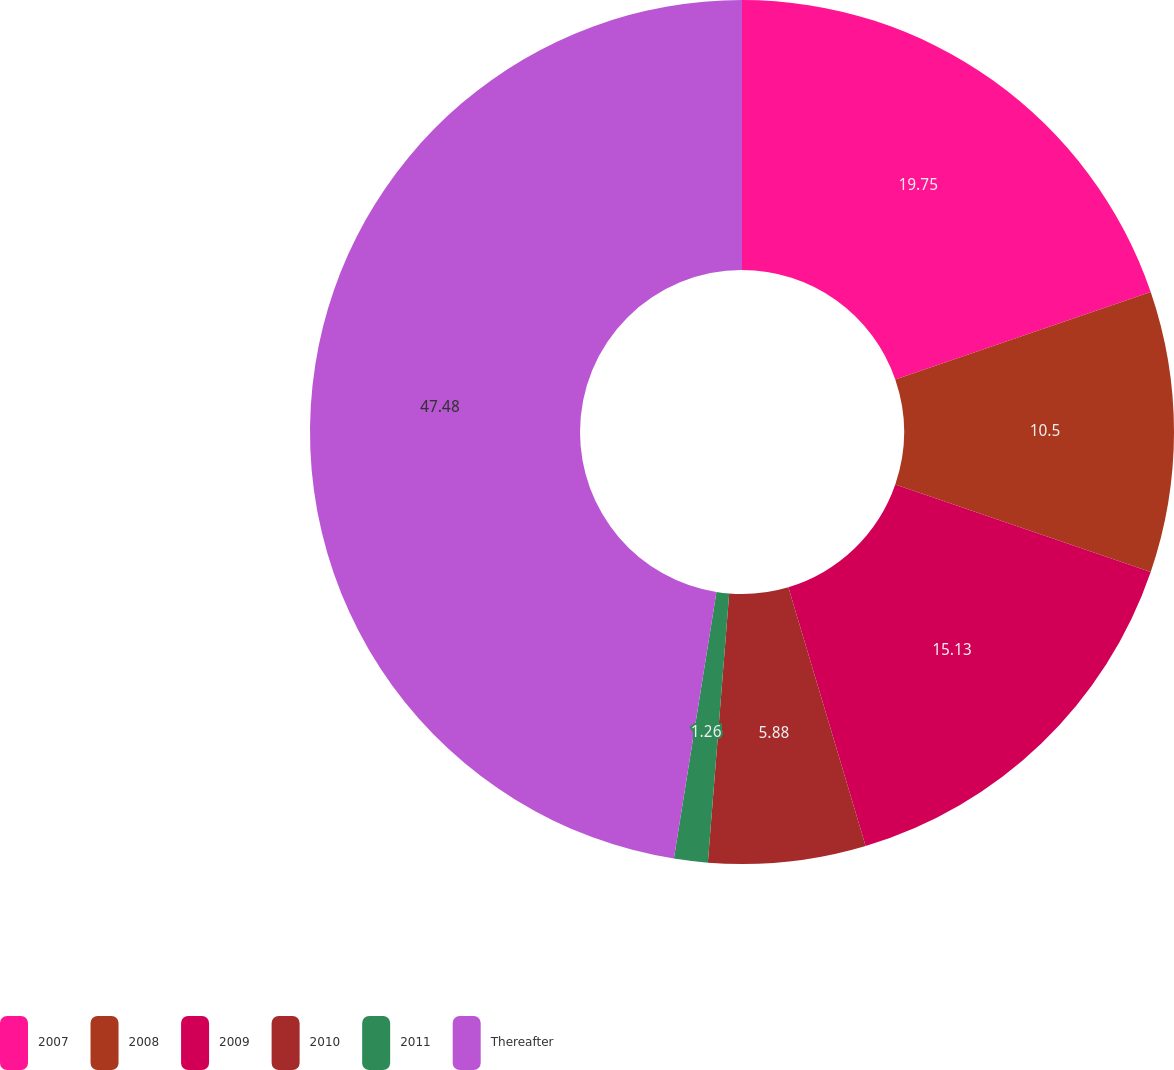Convert chart. <chart><loc_0><loc_0><loc_500><loc_500><pie_chart><fcel>2007<fcel>2008<fcel>2009<fcel>2010<fcel>2011<fcel>Thereafter<nl><fcel>19.75%<fcel>10.5%<fcel>15.13%<fcel>5.88%<fcel>1.26%<fcel>47.48%<nl></chart> 